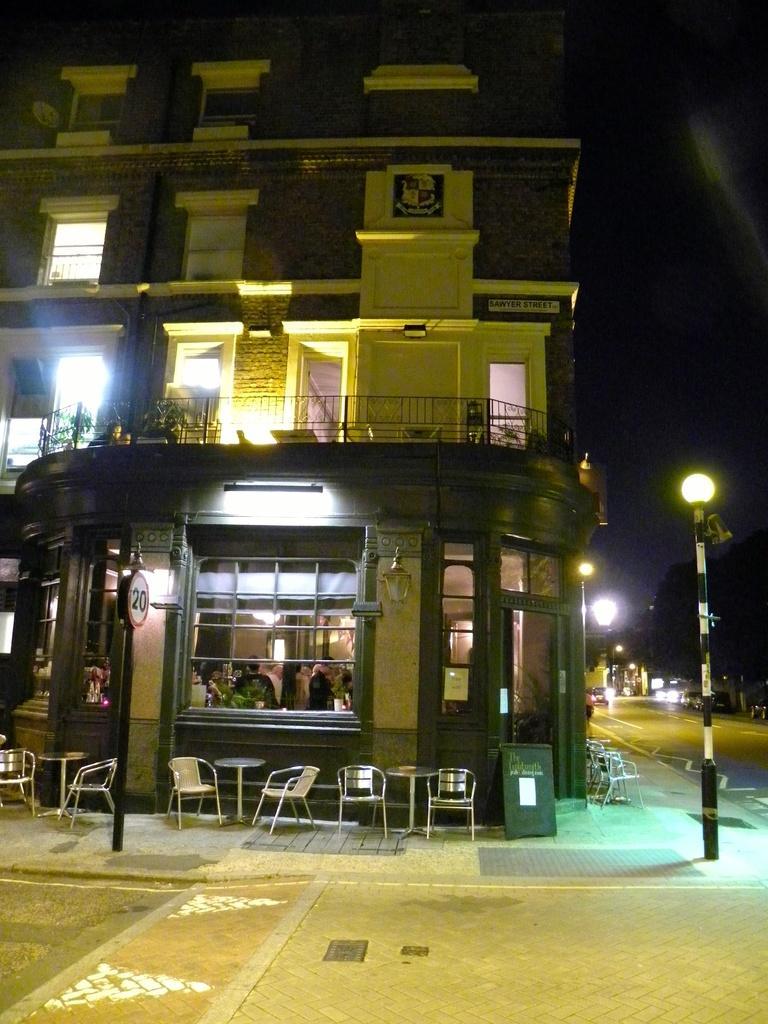Could you give a brief overview of what you see in this image? In this image we can see a building with windows and some people sitting inside it. We can also see a board, chairs, table, street pole, cars on the road and a tree. 